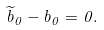Convert formula to latex. <formula><loc_0><loc_0><loc_500><loc_500>\widetilde { b } _ { 0 } - b _ { 0 } = 0 .</formula> 